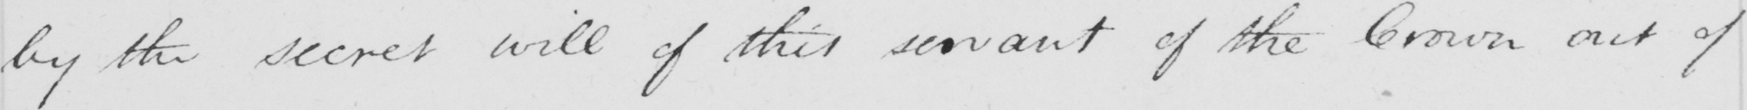Please transcribe the handwritten text in this image. by the secret will of this servant of the Crown out of 